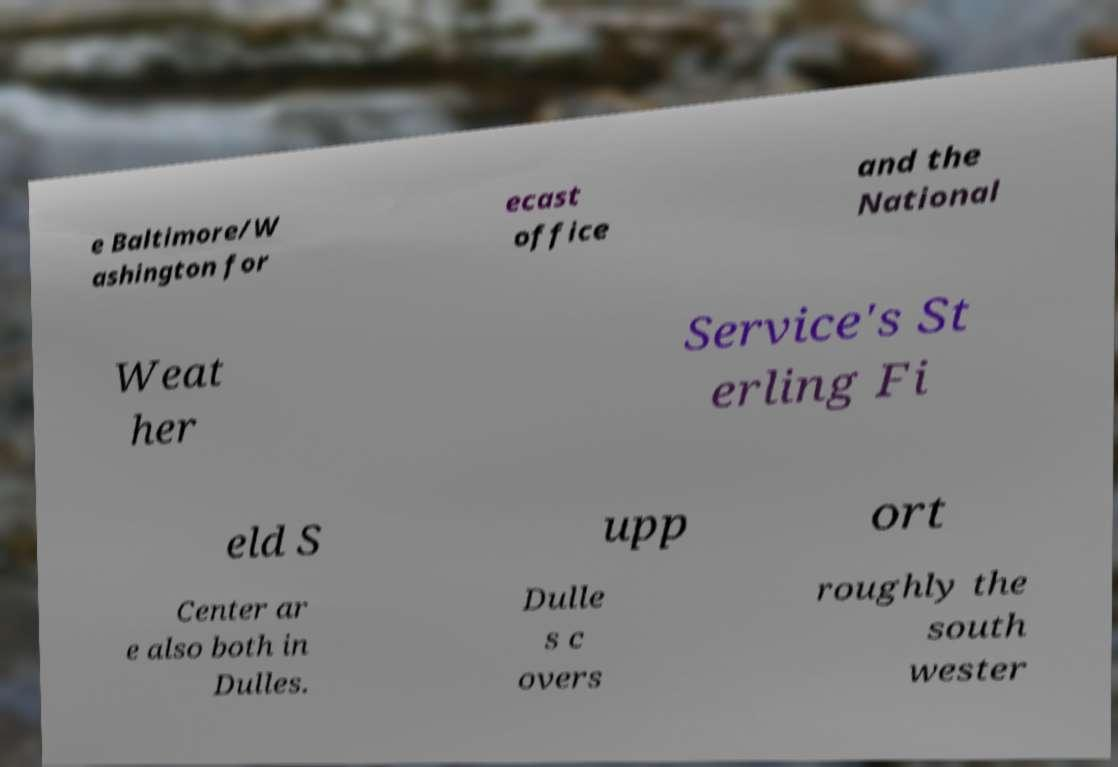Could you assist in decoding the text presented in this image and type it out clearly? e Baltimore/W ashington for ecast office and the National Weat her Service's St erling Fi eld S upp ort Center ar e also both in Dulles. Dulle s c overs roughly the south wester 